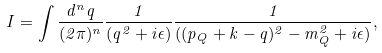Convert formula to latex. <formula><loc_0><loc_0><loc_500><loc_500>I = \int \frac { d ^ { n } q } { ( 2 \pi ) ^ { n } } \frac { 1 } { ( q ^ { 2 } + i \epsilon ) } \frac { 1 } { ( ( p _ { Q } + k - q ) ^ { 2 } - m _ { Q } ^ { 2 } + i \epsilon ) } ,</formula> 